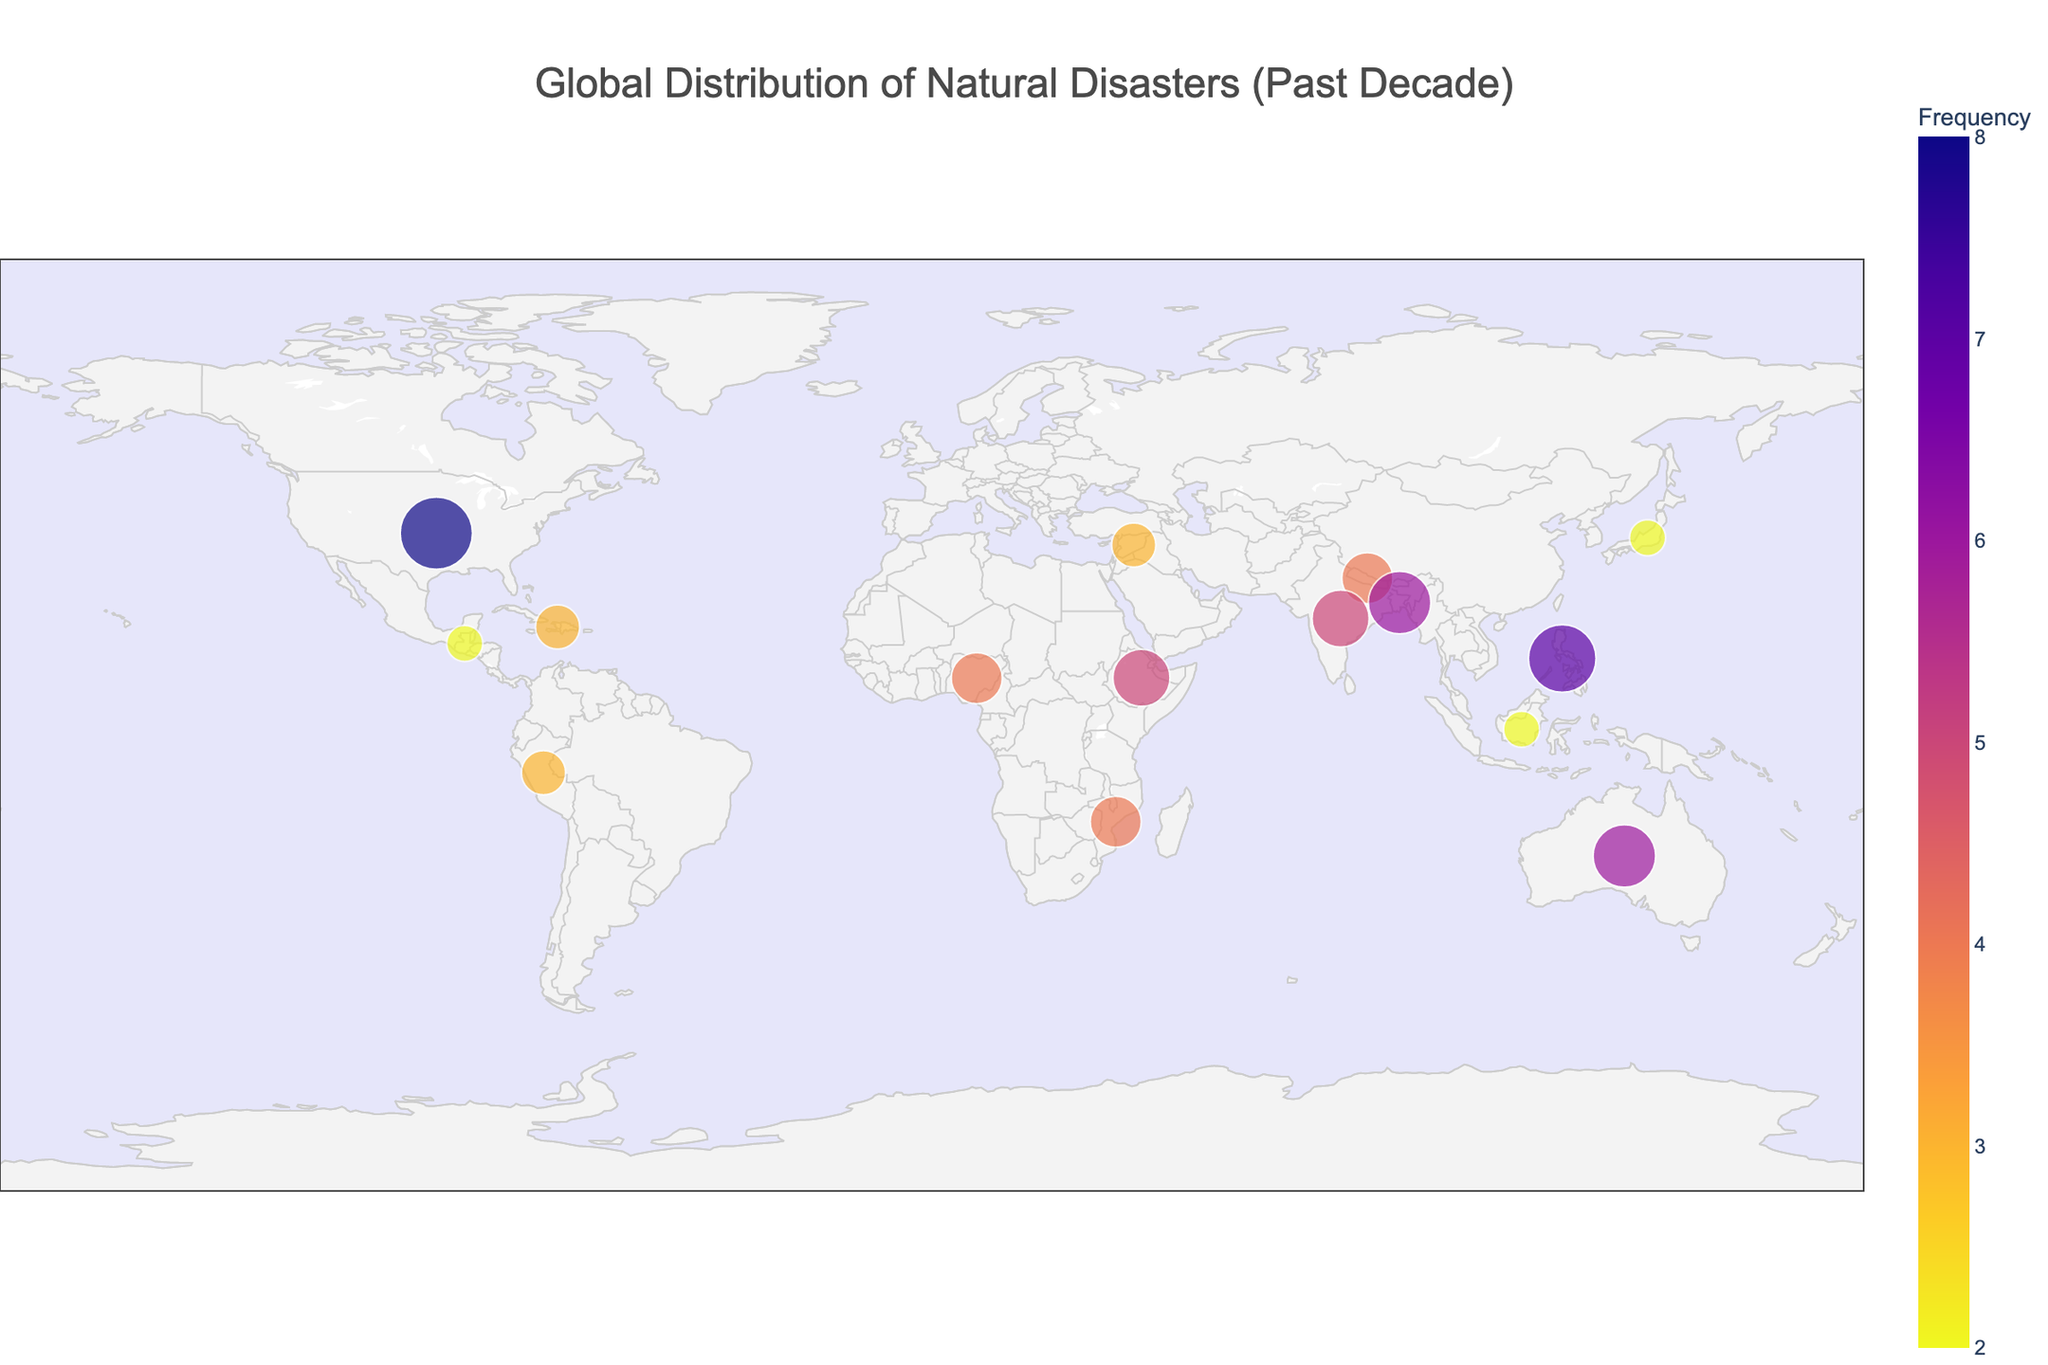What is the title of the plot? The title is usually located at the top center of the plot and describes the main focus of the visualized data.
Answer: Global Distribution of Natural Disasters (Past Decade) Which country has experienced the highest frequency of natural disasters? Examine the plot for the country with the largest circles or the highest value in the 'Frequency' color scale.
Answer: United States How many types of natural disasters are shown in the plot? Identify the different categories by examining the displayed hover information or the legend if available.
Answer: 13 types Which region (latitude and longitude) has the most variety of natural disasters? Look for the region with several points corresponding to different named natural disasters.
Answer: Latitude around 0-20 and Longitude around 90-120 Compare the frequency of natural disasters in Bangladesh and Australia. Which country experienced more, and by how much? Bangladesh has a frequency of 6 (Flood) and Australia has a frequency of 6 (Bushfire). The difference is 0.
Answer: They experienced the same number of disasters Which type of natural disaster occurred most frequently in the dataset? Check for the disaster type with the highest accumulated frequency across countries. This requires adding frequency values per disaster type.
Answer: Wildfire (United States) What country had the least frequent natural disasters and how many did they have? Identify the smallest circle or lightest color in the plot, and refer to its corresponding frequency.
Answer: Guatemala, 2 (Volcanic Eruption) Which continent shows higher vulnerability based on the number of different disaster types plotted? Locate the continents with the largest variety of disaster icons and sums the frequency for those regions.
Answer: Asia Are there more disasters with a frequency of 5 or higher or less than 5? Count the number of points/circles that have frequencies 5 or higher and those with less than 5.
Answer: More with a frequency of 5 or higher What is the frequency range represented in the plot? Look for the smallest and largest frequency values displayed in the plot.
Answer: 2 to 8 